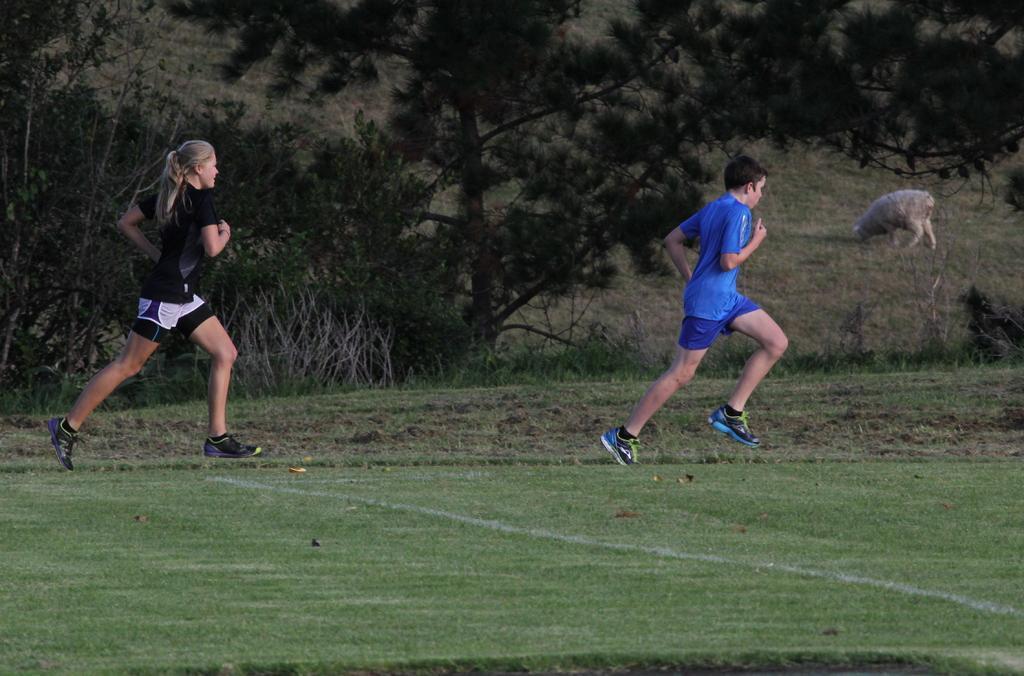How would you summarize this image in a sentence or two? In the picture there are two people running on the ground and behind them there are trees and pants, in the background there is an animal grazing the grass. 